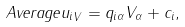<formula> <loc_0><loc_0><loc_500><loc_500>\ A v e r a g e { u _ { i } } _ { V } = q _ { i \alpha } V _ { \alpha } + c _ { i } ,</formula> 